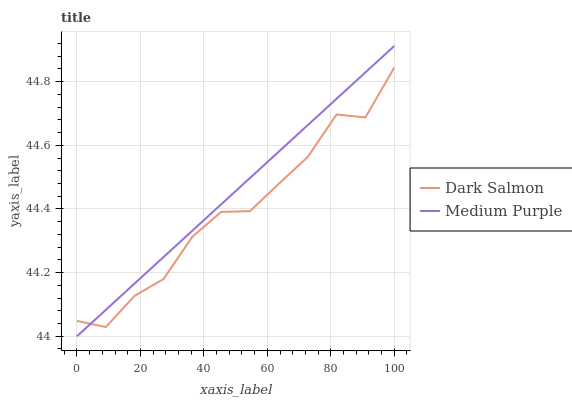Does Dark Salmon have the minimum area under the curve?
Answer yes or no. Yes. Does Medium Purple have the maximum area under the curve?
Answer yes or no. Yes. Does Dark Salmon have the maximum area under the curve?
Answer yes or no. No. Is Medium Purple the smoothest?
Answer yes or no. Yes. Is Dark Salmon the roughest?
Answer yes or no. Yes. Is Dark Salmon the smoothest?
Answer yes or no. No. Does Medium Purple have the lowest value?
Answer yes or no. Yes. Does Dark Salmon have the lowest value?
Answer yes or no. No. Does Medium Purple have the highest value?
Answer yes or no. Yes. Does Dark Salmon have the highest value?
Answer yes or no. No. Does Dark Salmon intersect Medium Purple?
Answer yes or no. Yes. Is Dark Salmon less than Medium Purple?
Answer yes or no. No. Is Dark Salmon greater than Medium Purple?
Answer yes or no. No. 